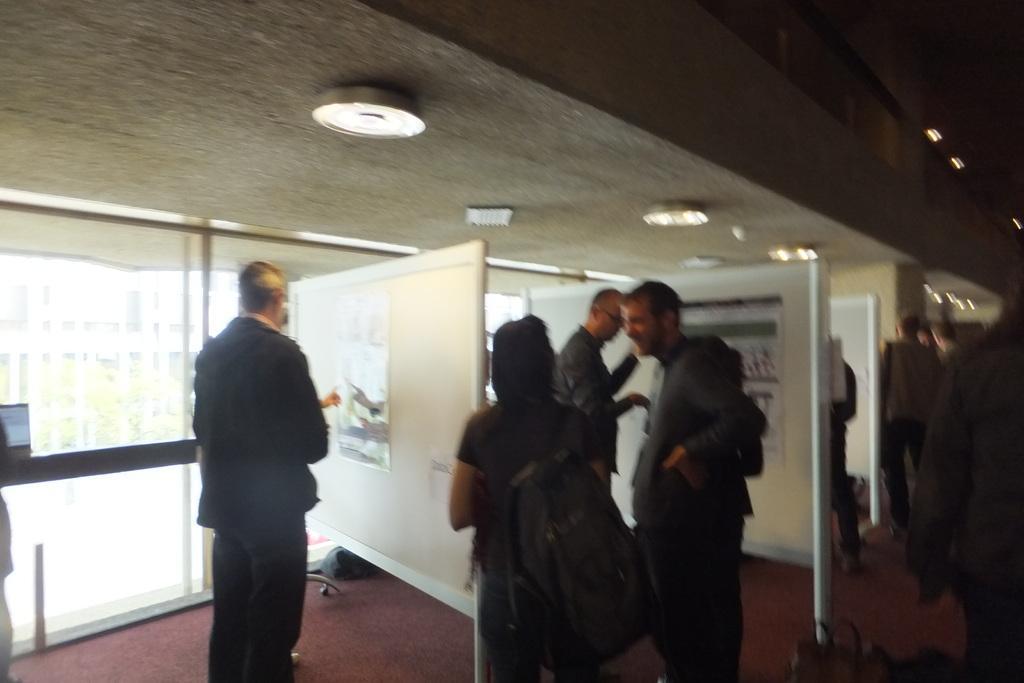In one or two sentences, can you explain what this image depicts? In this image, we can see a group of people standing and wearing clothes. There is a person at the bottom of the image wearing a bag. 